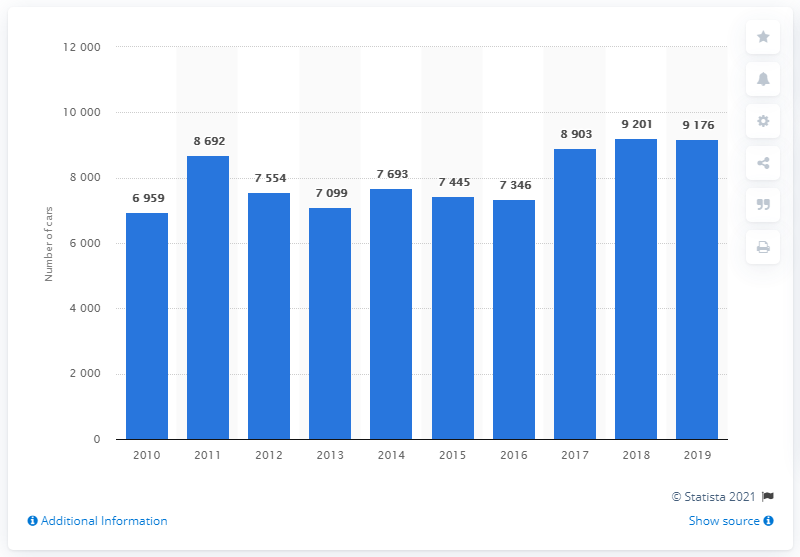Specify some key components in this picture. In 2018, a total of 9,176 Volvo cars were sold in Finland. 